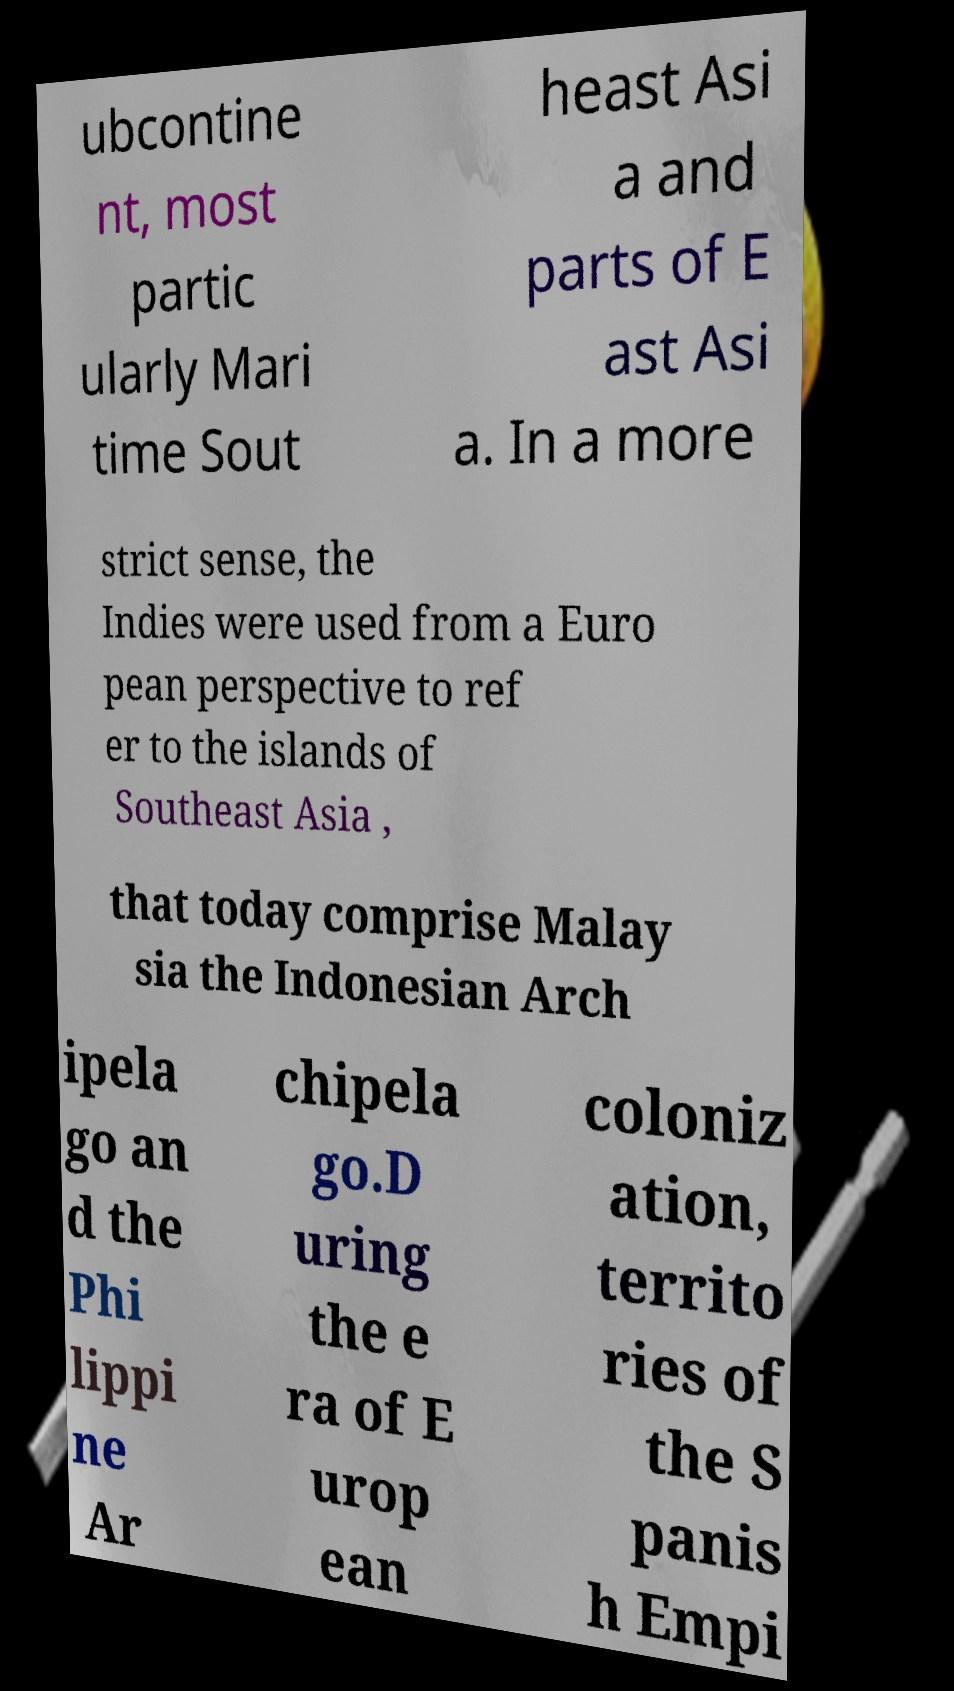Please read and relay the text visible in this image. What does it say? ubcontine nt, most partic ularly Mari time Sout heast Asi a and parts of E ast Asi a. In a more strict sense, the Indies were used from a Euro pean perspective to ref er to the islands of Southeast Asia , that today comprise Malay sia the Indonesian Arch ipela go an d the Phi lippi ne Ar chipela go.D uring the e ra of E urop ean coloniz ation, territo ries of the S panis h Empi 